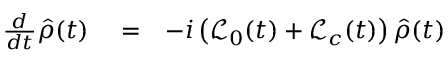<formula> <loc_0><loc_0><loc_500><loc_500>\begin{array} { r l r } { \frac { d } { d t } \hat { \rho } ( t ) } & = } & { - i \left ( { \mathcal { L } } _ { 0 } ( t ) + { \mathcal { L } } _ { c } ( t ) \right ) \hat { \rho } ( t ) } \end{array}</formula> 